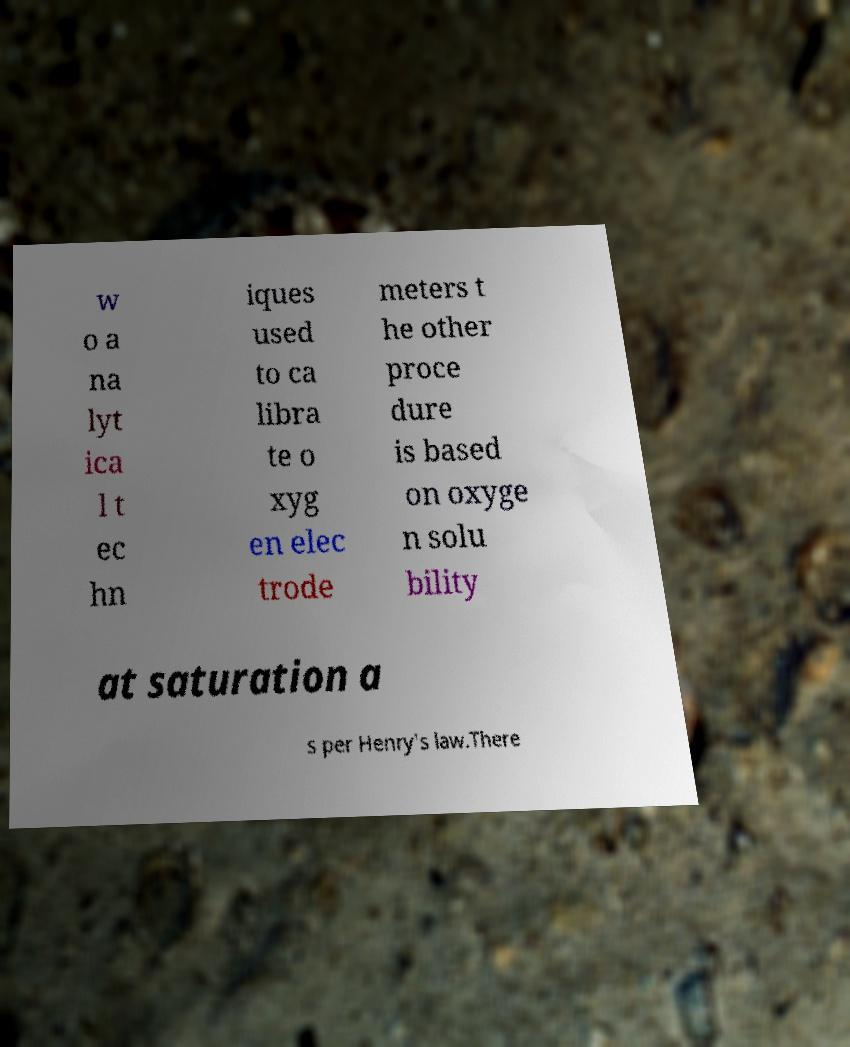Could you extract and type out the text from this image? w o a na lyt ica l t ec hn iques used to ca libra te o xyg en elec trode meters t he other proce dure is based on oxyge n solu bility at saturation a s per Henry's law.There 